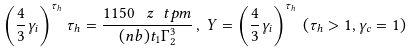Convert formula to latex. <formula><loc_0><loc_0><loc_500><loc_500>\left ( \frac { 4 } { 3 } \gamma _ { i } \right ) ^ { \tau _ { h } } \tau _ { h } = \frac { 1 1 5 0 \, \ z \ t p m } { ( n b ) t _ { 1 } \Gamma _ { 2 } ^ { 3 } } \, , \, Y = \left ( \frac { 4 } { 3 } \gamma _ { i } \right ) ^ { \tau _ { h } } \, ( \tau _ { h } > 1 , \gamma _ { c } = 1 )</formula> 